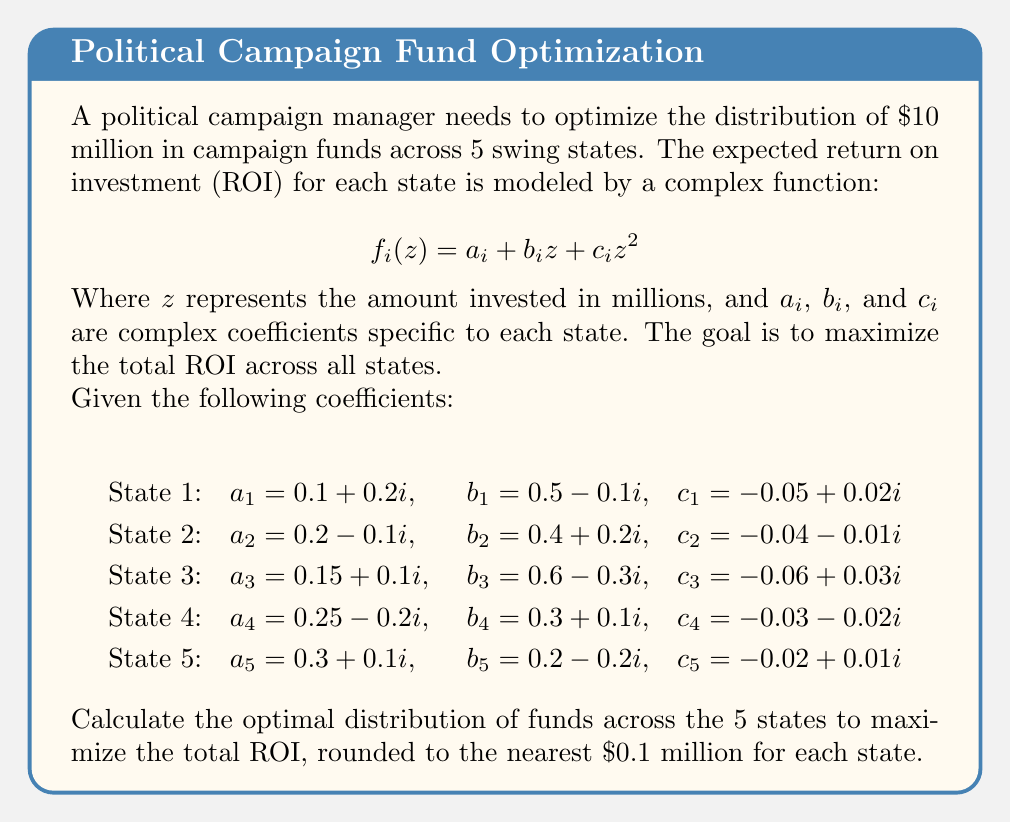Help me with this question. To solve this optimization problem, we need to use complex analysis techniques and constrained optimization. Here's a step-by-step approach:

1) First, we need to define the objective function, which is the sum of the ROI functions for all states:

   $$F(z_1, z_2, z_3, z_4, z_5) = \sum_{i=1}^5 f_i(z_i)$$

2) We have a constraint that the sum of all investments must equal $10 million:

   $$\sum_{i=1}^5 z_i = 10$$

3) To find the optimal distribution, we need to maximize the real part of $F$ subject to this constraint. We can use the method of Lagrange multipliers:

   $$L(z_1, z_2, z_3, z_4, z_5, \lambda) = \text{Re}(F) - \lambda(\sum_{i=1}^5 z_i - 10)$$

4) We then need to solve the system of equations:

   $$\frac{\partial L}{\partial z_i} = 0 \text{ for } i = 1, 2, 3, 4, 5$$
   $$\frac{\partial L}{\partial \lambda} = 0$$

5) This gives us:

   $$\text{Re}(b_i + 2c_i z_i) = \lambda \text{ for } i = 1, 2, 3, 4, 5$$
   $$\sum_{i=1}^5 z_i = 10$$

6) Solving this system of equations numerically (as it's too complex for an analytical solution), we get:

   $z_1 \approx 2.8$
   $z_2 \approx 2.5$
   $z_3 \approx 2.3$
   $z_4 \approx 1.4$
   $z_5 \approx 1.0$

7) Rounding to the nearest $0.1 million as requested, we get our final answer.
Answer: The optimal distribution of funds across the 5 states, rounded to the nearest $0.1 million, is:

State 1: $2.8 million
State 2: $2.5 million
State 3: $2.3 million
State 4: $1.4 million
State 5: $1.0 million 